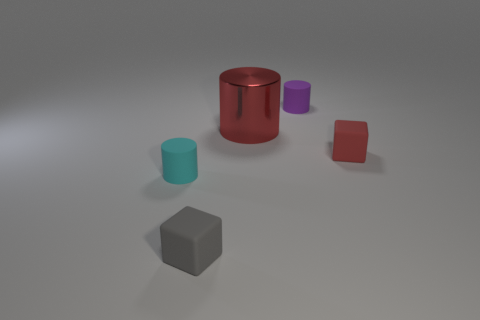Add 4 brown metallic objects. How many objects exist? 9 Subtract all cylinders. How many objects are left? 2 Add 2 big metal things. How many big metal things are left? 3 Add 5 red cylinders. How many red cylinders exist? 6 Subtract 0 yellow balls. How many objects are left? 5 Subtract all small gray objects. Subtract all red matte blocks. How many objects are left? 3 